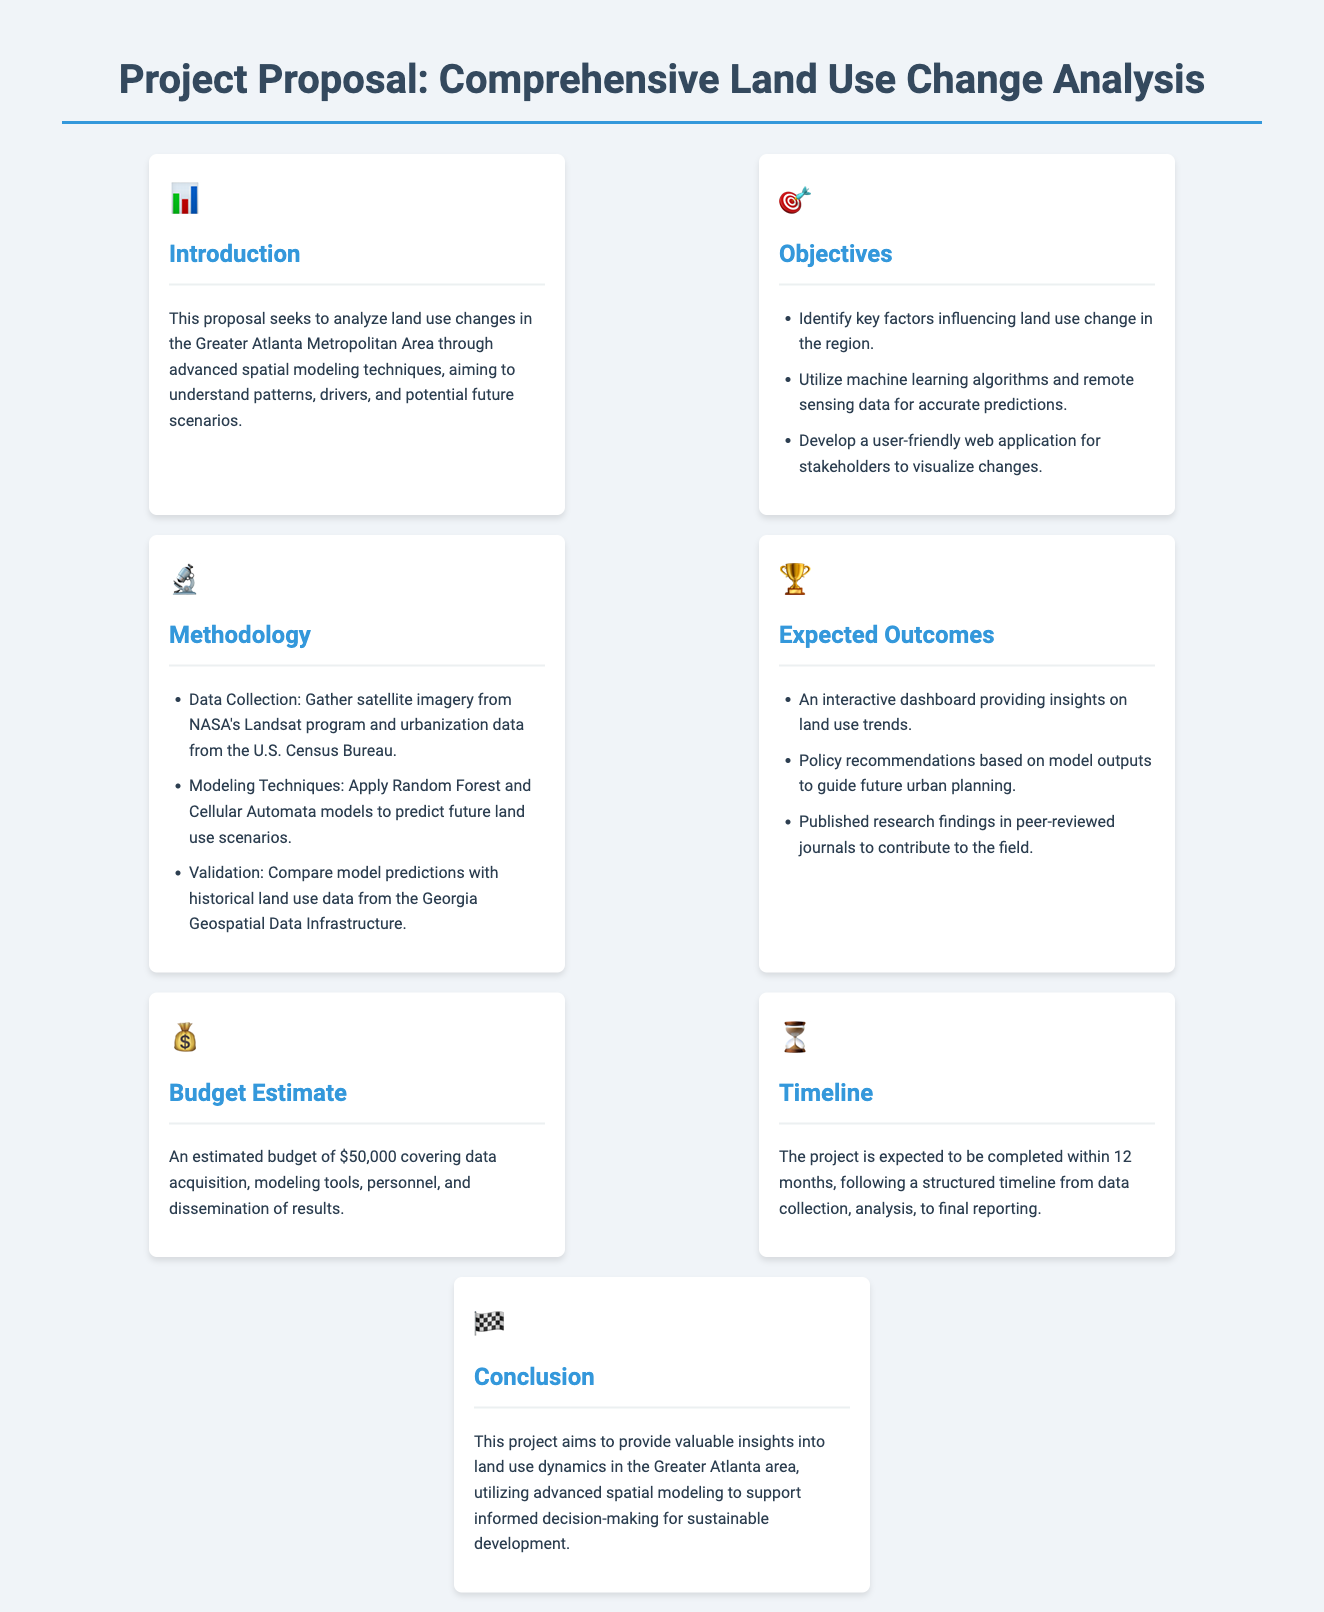What is the title of the project proposal? The title of the project proposal is located at the top of the document.
Answer: Project Proposal: Comprehensive Land Use Change Analysis How much is the estimated budget for the project? The estimated budget is mentioned in the Budget Estimate section of the document.
Answer: $50,000 What methodology will be used for modeling? The modeling techniques are listed in the Methodology section, detailing specific approaches.
Answer: Random Forest and Cellular Automata What is one expected outcome of the project? The expected outcomes are outlined in the Expected Outcomes section, providing insights on land use trends.
Answer: An interactive dashboard providing insights on land use trends How long is the projected timeline for completion? The timeline for completion is detailed in the Timeline section of the document.
Answer: 12 months What data source is mentioned for satellite imagery? The introduction mentions a specific data source for satellite imagery.
Answer: NASA's Landsat program What type of application will be developed for stakeholders? The types of applications are described in the Objectives section of the document.
Answer: A user-friendly web application What area is the focus of the land use change analysis? The region of focus is specified in the introduction of the document.
Answer: Greater Atlanta Metropolitan Area Which organization’s data will be used for urbanization data? The document specifies the organization providing urbanization data in the Methodology section.
Answer: U.S. Census Bureau 